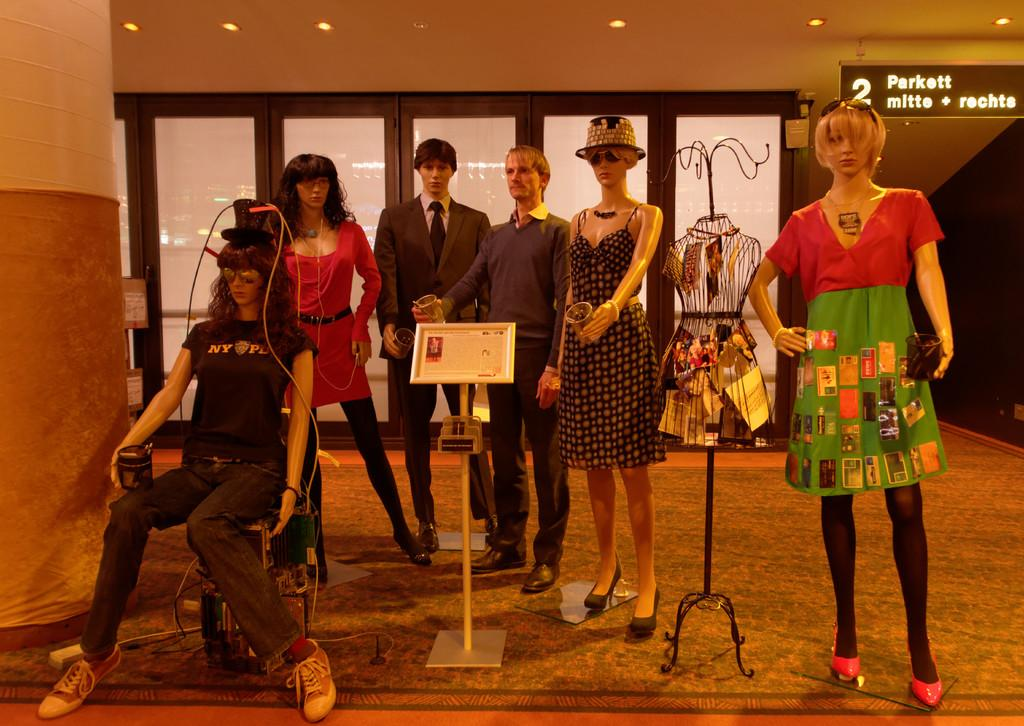What type of figures can be seen in the image? There are mannequins in the image. What is behind the mannequins? There is a wall behind the mannequins. What is visible at the top of the image? The roof is visible at the top of the image, along with lights and a banner. How many trucks are parked next to the mannequins in the image? There are no trucks present in the image; it only features mannequins, a wall, and elements at the top of the image. What type of bag is being carried by the goat in the image? There is no goat present in the image, so it is not possible to determine if a bag is being carried. 